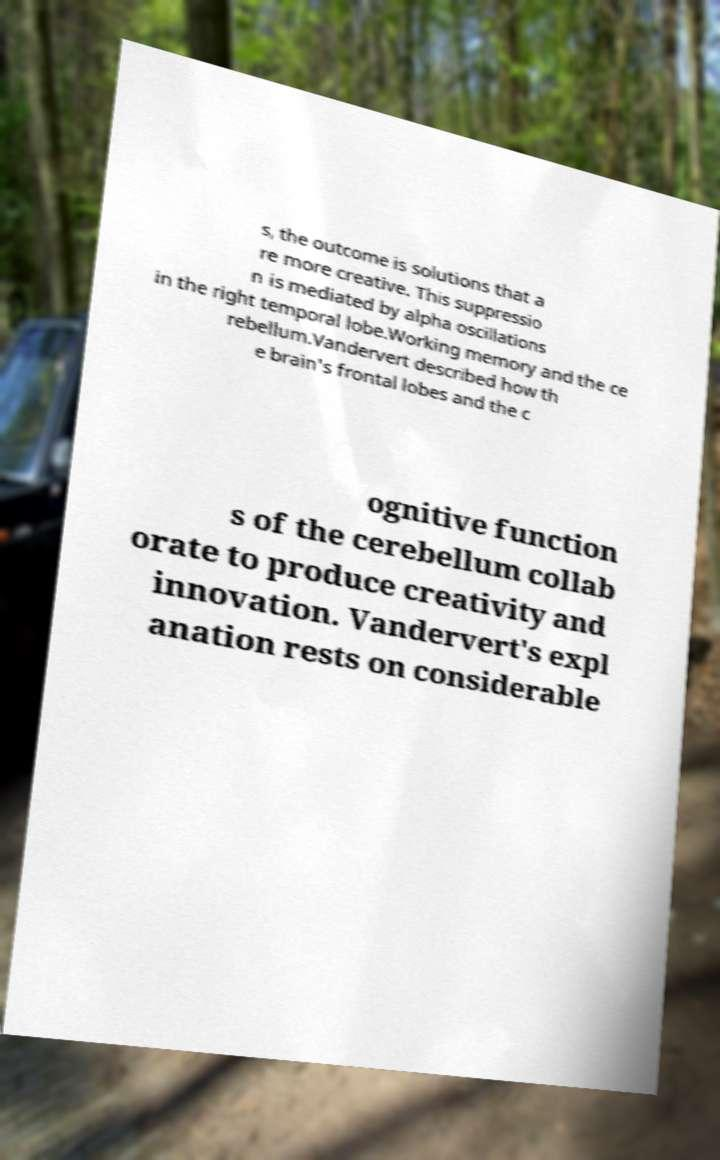There's text embedded in this image that I need extracted. Can you transcribe it verbatim? s, the outcome is solutions that a re more creative. This suppressio n is mediated by alpha oscillations in the right temporal lobe.Working memory and the ce rebellum.Vandervert described how th e brain's frontal lobes and the c ognitive function s of the cerebellum collab orate to produce creativity and innovation. Vandervert's expl anation rests on considerable 